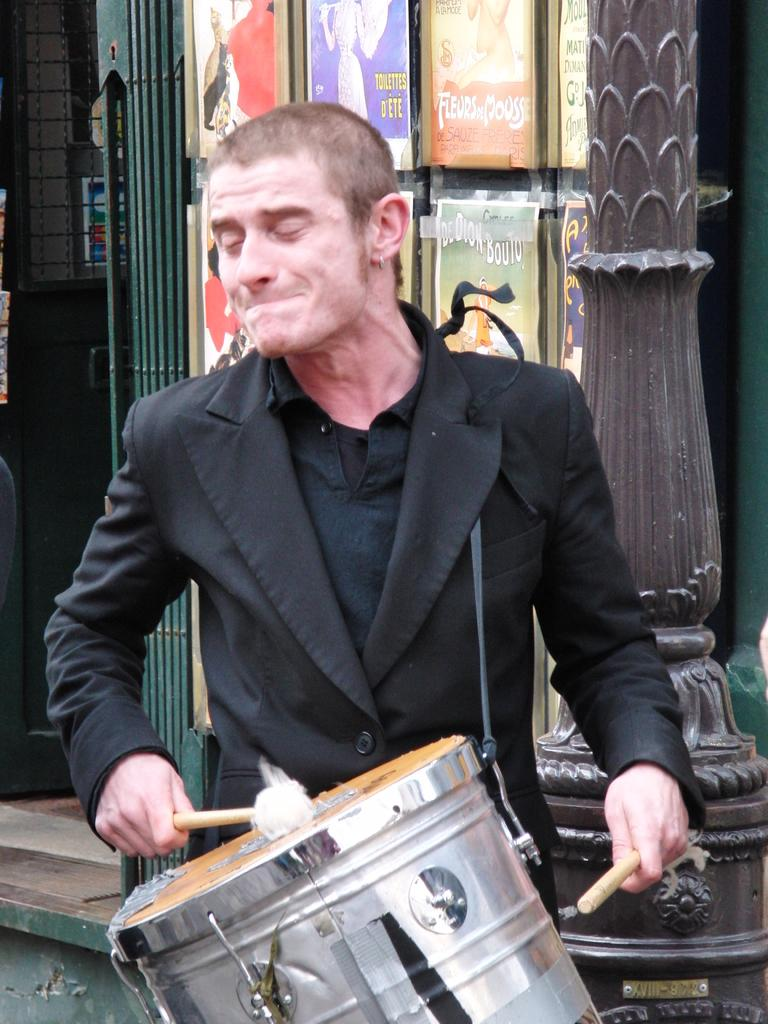What is the man in the image doing? The man is playing a drum. What else can be seen in the image besides the man playing the drum? There are posters in the image. What color is the vein in the man's arm in the image? There is no visible vein in the man's arm in the image, and therefore no color can be determined. 